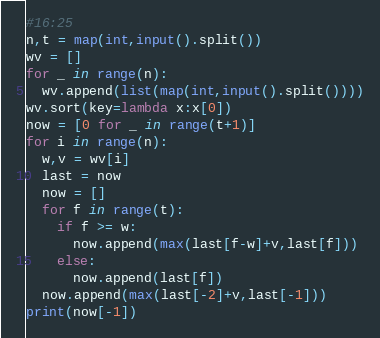Convert code to text. <code><loc_0><loc_0><loc_500><loc_500><_Python_>#16:25
n,t = map(int,input().split())
wv = []
for _ in range(n):
  wv.append(list(map(int,input().split())))
wv.sort(key=lambda x:x[0])
now = [0 for _ in range(t+1)]
for i in range(n):
  w,v = wv[i]
  last = now
  now = []
  for f in range(t):
    if f >= w:
      now.append(max(last[f-w]+v,last[f]))
    else:
      now.append(last[f])
  now.append(max(last[-2]+v,last[-1]))
print(now[-1])</code> 